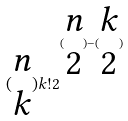<formula> <loc_0><loc_0><loc_500><loc_500>( \begin{matrix} n \\ k \end{matrix} ) k ! 2 ^ { ( \begin{matrix} n \\ 2 \end{matrix} ) - ( \begin{matrix} k \\ 2 \end{matrix} ) }</formula> 